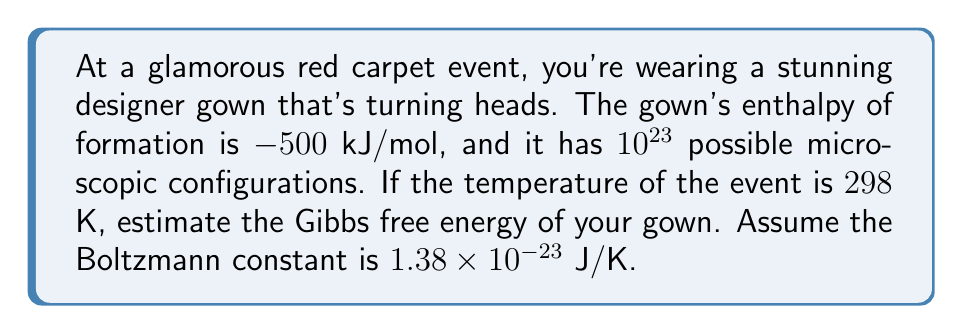Help me with this question. Let's approach this step-by-step:

1) The Gibbs free energy (G) is given by the equation:

   $$G = H - TS$$

   where H is enthalpy, T is temperature, and S is entropy.

2) We're given the enthalpy (H) directly:

   $$H = -500 \text{ kJ/mol} = -500,000 \text{ J/mol}$$

3) For entropy, we can use Boltzmann's equation:

   $$S = k_B \ln \Omega$$

   where $k_B$ is the Boltzmann constant and $\Omega$ is the number of microstates.

4) Calculating entropy:

   $$S = (1.38 \times 10^{-23} \text{ J/K}) \times \ln(10^{23})$$
   $$S = (1.38 \times 10^{-23} \text{ J/K}) \times 23 \ln(10)$$
   $$S = 7.3 \times 10^{-22} \text{ J/K}$$

5) Now we can calculate TS:

   $$TS = (298 \text{ K}) \times (7.3 \times 10^{-22} \text{ J/K}) = 2.18 \times 10^{-19} \text{ J}$$

6) Finally, we can calculate the Gibbs free energy:

   $$G = H - TS$$
   $$G = -500,000 \text{ J/mol} - 2.18 \times 10^{-19} \text{ J}$$
   $$G \approx -500,000 \text{ J/mol}$$

The TS term is negligibly small compared to the enthalpy, so it doesn't significantly affect the result.
Answer: $-500,000 \text{ J/mol}$ 